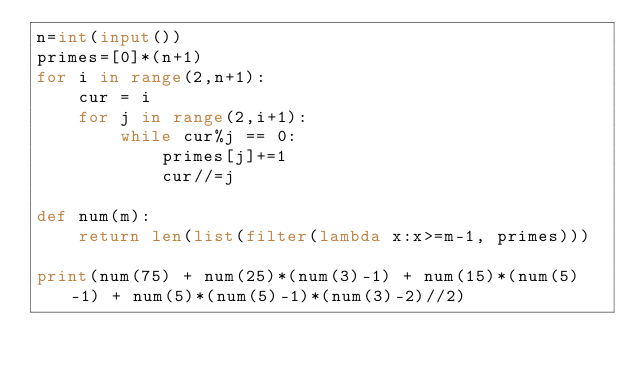Convert code to text. <code><loc_0><loc_0><loc_500><loc_500><_Python_>n=int(input())
primes=[0]*(n+1)
for i in range(2,n+1):
    cur = i
    for j in range(2,i+1):
        while cur%j == 0:
            primes[j]+=1
            cur//=j

def num(m):
    return len(list(filter(lambda x:x>=m-1, primes)))

print(num(75) + num(25)*(num(3)-1) + num(15)*(num(5)-1) + num(5)*(num(5)-1)*(num(3)-2)//2)
</code> 